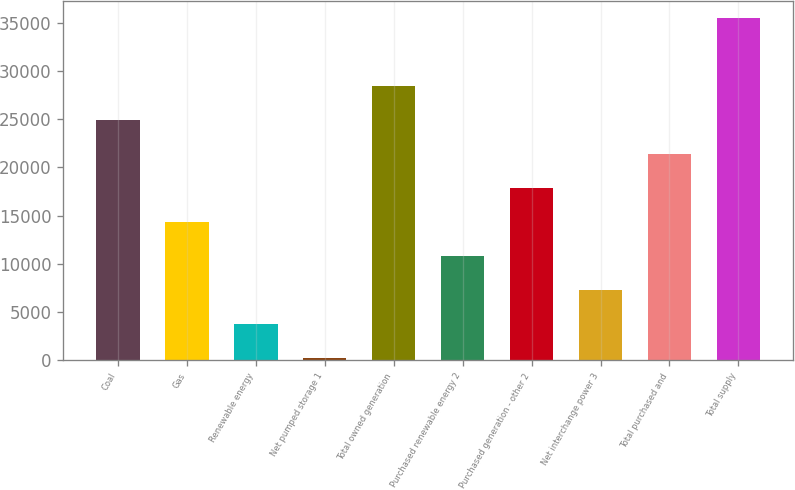<chart> <loc_0><loc_0><loc_500><loc_500><bar_chart><fcel>Coal<fcel>Gas<fcel>Renewable energy<fcel>Net pumped storage 1<fcel>Total owned generation<fcel>Purchased renewable energy 2<fcel>Purchased generation - other 2<fcel>Net interchange power 3<fcel>Total purchased and<fcel>Total supply<nl><fcel>24915.6<fcel>14317.2<fcel>3718.8<fcel>186<fcel>28448.4<fcel>10784.4<fcel>17850<fcel>7251.6<fcel>21382.8<fcel>35514<nl></chart> 